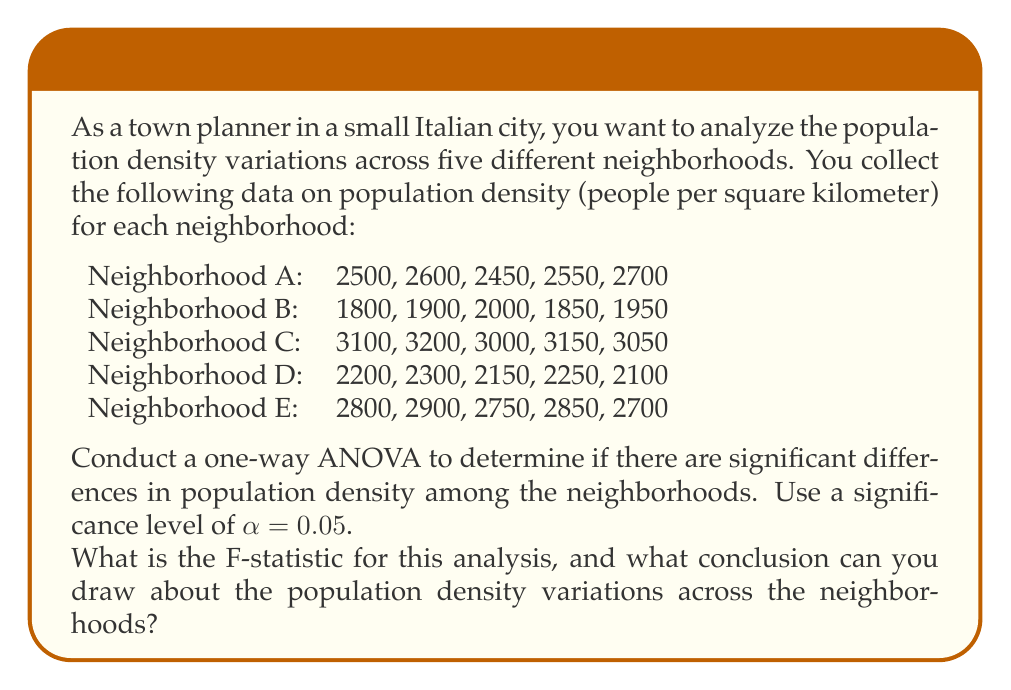Could you help me with this problem? To conduct a one-way ANOVA, we need to follow these steps:

1. Calculate the sum of squares between groups (SSB), sum of squares within groups (SSW), and total sum of squares (SST).
2. Calculate the degrees of freedom for between groups (dfB), within groups (dfW), and total (dfT).
3. Calculate the mean square between groups (MSB) and mean square within groups (MSW).
4. Calculate the F-statistic.
5. Compare the F-statistic to the critical F-value or use the p-value to make a conclusion.

Step 1: Calculate sums of squares

First, let's calculate the grand mean:
$$ \bar{X} = \frac{2500 + 2600 + ... + 2850 + 2700}{25} = 2510 $$

Now, we can calculate SSB, SSW, and SST:

SSB = $\sum_{i=1}^{k} n_i(\bar{X_i} - \bar{X})^2$
    = 5[(2560 - 2510)^2 + (1900 - 2510)^2 + (3100 - 2510)^2 + (2200 - 2510)^2 + (2800 - 2510)^2]$
    = 5,130,000

SSW = $\sum_{i=1}^{k} \sum_{j=1}^{n_i} (X_{ij} - \bar{X_i})^2$
    = [(2500 - 2560)^2 + ... + (2700 - 2800)^2]$
    = 170,000

SST = SSB + SSW = 5,130,000 + 170,000 = 5,300,000

Step 2: Calculate degrees of freedom

dfB = k - 1 = 5 - 1 = 4
dfW = N - k = 25 - 5 = 20
dfT = N - 1 = 25 - 1 = 24

Step 3: Calculate mean squares

MSB = SSB / dfB = 5,130,000 / 4 = 1,282,500
MSW = SSW / dfW = 170,000 / 20 = 8,500

Step 4: Calculate F-statistic

$$ F = \frac{MSB}{MSW} = \frac{1,282,500}{8,500} = 150.88 $$

Step 5: Compare F-statistic to critical F-value

The critical F-value for α = 0.05, dfB = 4, and dfW = 20 is approximately 2.87.

Since our calculated F-statistic (150.88) is much larger than the critical F-value (2.87), we reject the null hypothesis.
Answer: The F-statistic for this analysis is 150.88. We can conclude that there are significant differences in population density among the neighborhoods, as the F-statistic (150.88) is much larger than the critical F-value (2.87) at α = 0.05. This suggests that the variations in population density across the neighborhoods are statistically significant and not due to random chance. 